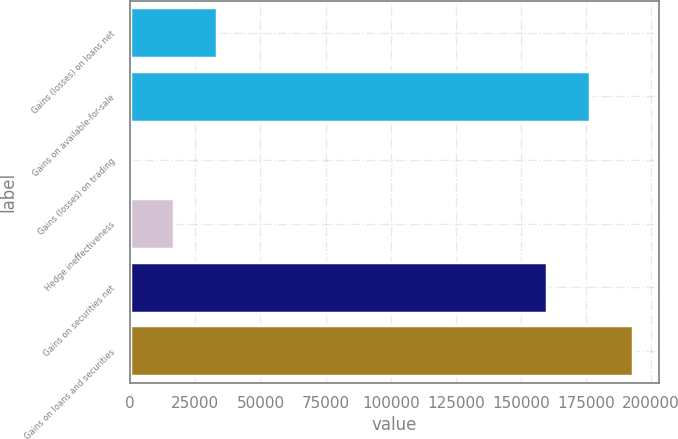Convert chart to OTSL. <chart><loc_0><loc_0><loc_500><loc_500><bar_chart><fcel>Gains (losses) on loans net<fcel>Gains on available-for-sale<fcel>Gains (losses) on trading<fcel>Hedge ineffectiveness<fcel>Gains on securities net<fcel>Gains on loans and securities<nl><fcel>33372<fcel>176551<fcel>162<fcel>16767<fcel>159946<fcel>193156<nl></chart> 